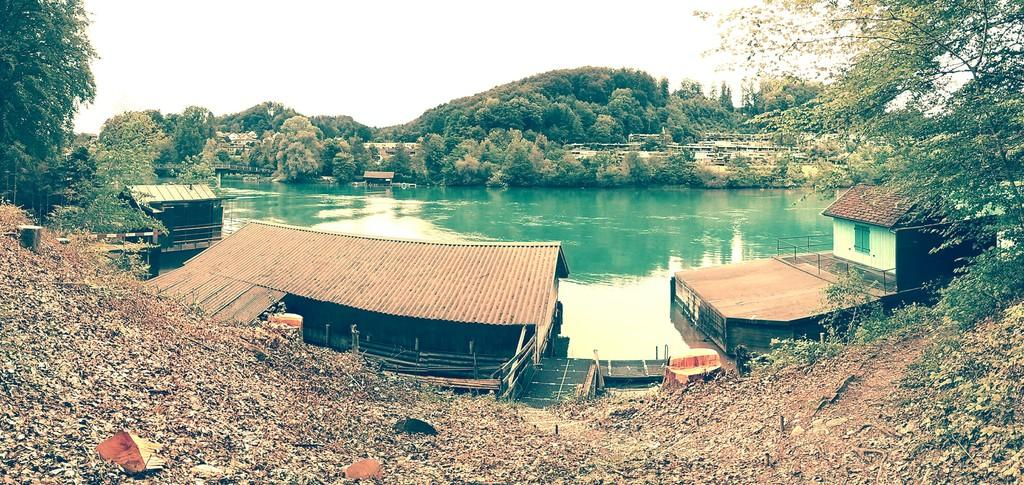What type of structures are visible in the image? There are iron houses and sheds in the image. What can be seen in the middle of the image? There appears to be a pond in the middle of the image. What type of vegetation is at the back side of the image? There are trees at the back side of the image. What is visible at the top of the image? The sky is visible at the top of the image. What type of cork is floating on the pond in the image? There is no cork present in the image; it features a pond with no visible objects floating on it. What knowledge can be gained from the image about the history of the area? The image does not provide any information about the history of the area, as it only shows the current state of the structures, pond, and trees. 